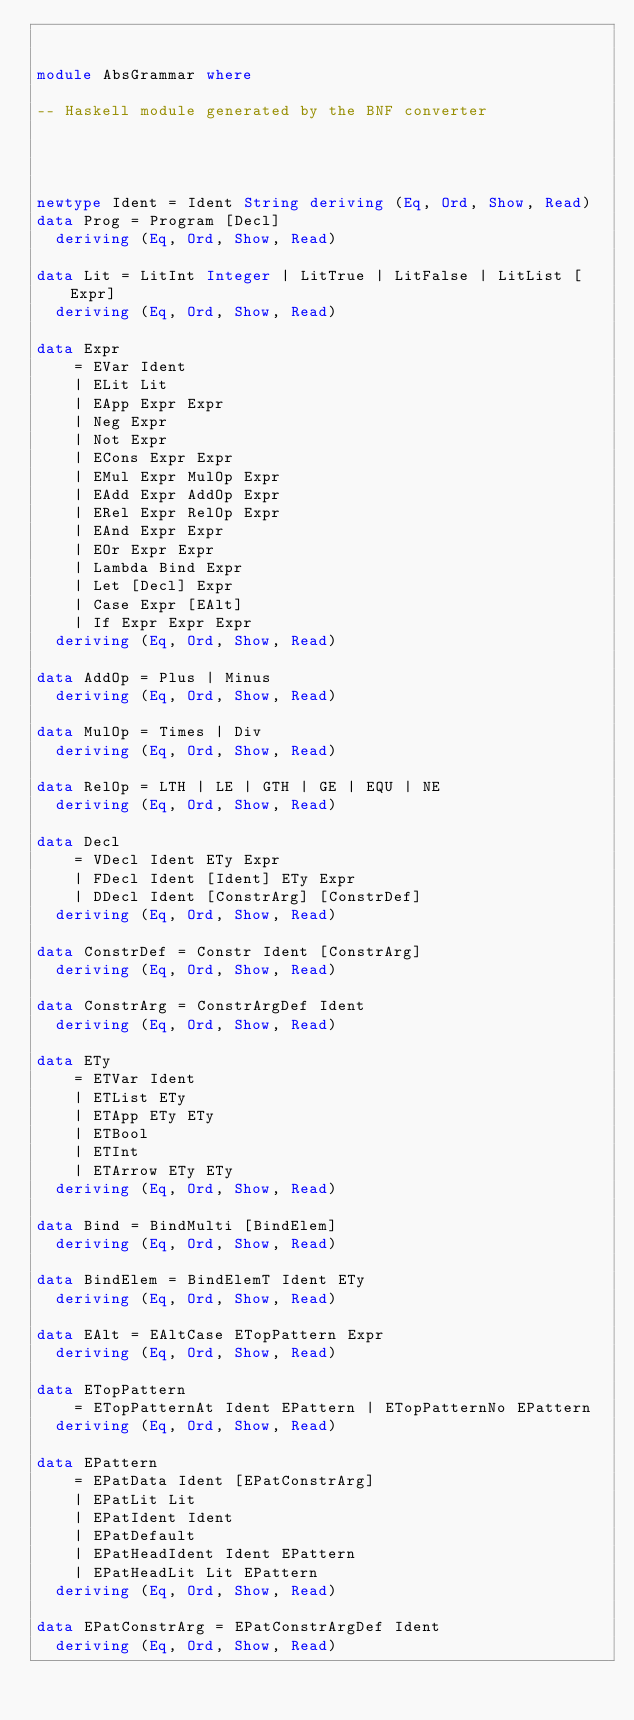<code> <loc_0><loc_0><loc_500><loc_500><_Haskell_>

module AbsGrammar where

-- Haskell module generated by the BNF converter




newtype Ident = Ident String deriving (Eq, Ord, Show, Read)
data Prog = Program [Decl]
  deriving (Eq, Ord, Show, Read)

data Lit = LitInt Integer | LitTrue | LitFalse | LitList [Expr]
  deriving (Eq, Ord, Show, Read)

data Expr
    = EVar Ident
    | ELit Lit
    | EApp Expr Expr
    | Neg Expr
    | Not Expr
    | ECons Expr Expr
    | EMul Expr MulOp Expr
    | EAdd Expr AddOp Expr
    | ERel Expr RelOp Expr
    | EAnd Expr Expr
    | EOr Expr Expr
    | Lambda Bind Expr
    | Let [Decl] Expr
    | Case Expr [EAlt]
    | If Expr Expr Expr
  deriving (Eq, Ord, Show, Read)

data AddOp = Plus | Minus
  deriving (Eq, Ord, Show, Read)

data MulOp = Times | Div
  deriving (Eq, Ord, Show, Read)

data RelOp = LTH | LE | GTH | GE | EQU | NE
  deriving (Eq, Ord, Show, Read)

data Decl
    = VDecl Ident ETy Expr
    | FDecl Ident [Ident] ETy Expr
    | DDecl Ident [ConstrArg] [ConstrDef]
  deriving (Eq, Ord, Show, Read)

data ConstrDef = Constr Ident [ConstrArg]
  deriving (Eq, Ord, Show, Read)

data ConstrArg = ConstrArgDef Ident
  deriving (Eq, Ord, Show, Read)

data ETy
    = ETVar Ident
    | ETList ETy
    | ETApp ETy ETy
    | ETBool
    | ETInt
    | ETArrow ETy ETy
  deriving (Eq, Ord, Show, Read)

data Bind = BindMulti [BindElem]
  deriving (Eq, Ord, Show, Read)

data BindElem = BindElemT Ident ETy
  deriving (Eq, Ord, Show, Read)

data EAlt = EAltCase ETopPattern Expr
  deriving (Eq, Ord, Show, Read)

data ETopPattern
    = ETopPatternAt Ident EPattern | ETopPatternNo EPattern
  deriving (Eq, Ord, Show, Read)

data EPattern
    = EPatData Ident [EPatConstrArg]
    | EPatLit Lit
    | EPatIdent Ident
    | EPatDefault
    | EPatHeadIdent Ident EPattern
    | EPatHeadLit Lit EPattern
  deriving (Eq, Ord, Show, Read)

data EPatConstrArg = EPatConstrArgDef Ident
  deriving (Eq, Ord, Show, Read)

</code> 